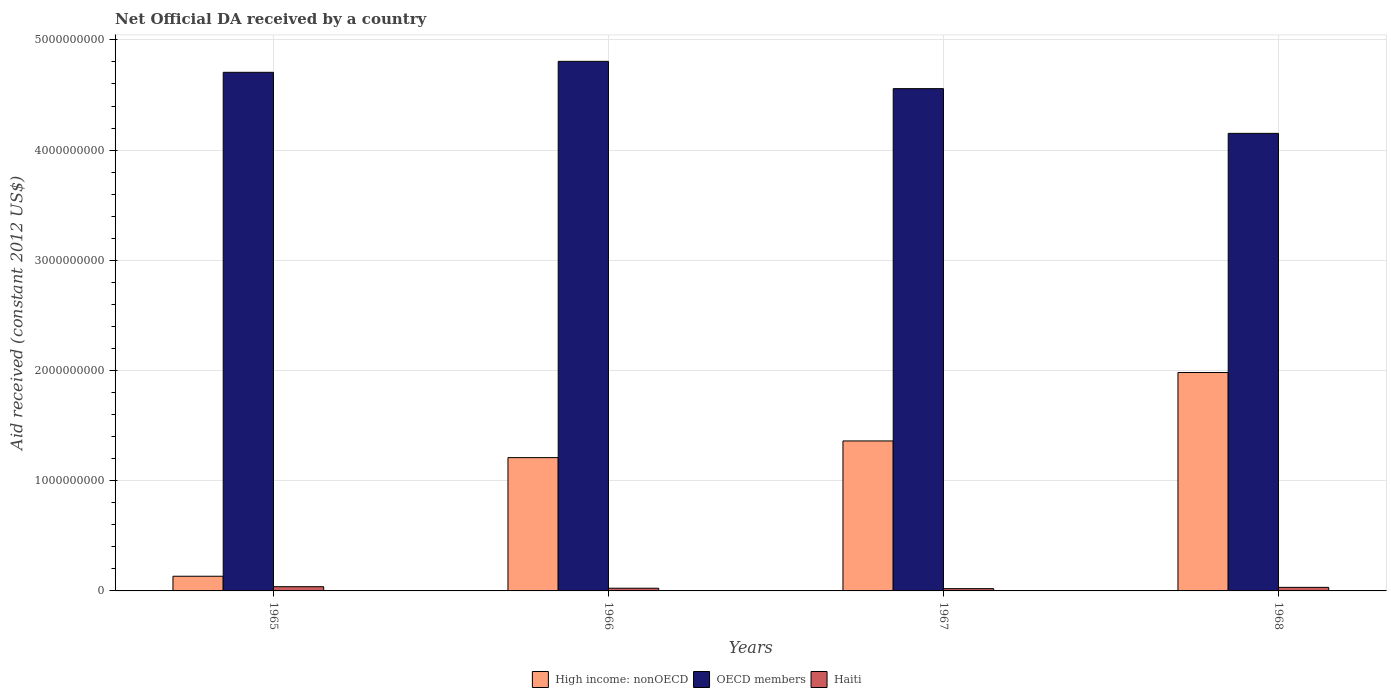Are the number of bars per tick equal to the number of legend labels?
Provide a short and direct response. Yes. Are the number of bars on each tick of the X-axis equal?
Offer a very short reply. Yes. How many bars are there on the 3rd tick from the left?
Provide a succinct answer. 3. What is the label of the 3rd group of bars from the left?
Your response must be concise. 1967. What is the net official development assistance aid received in Haiti in 1967?
Provide a short and direct response. 2.07e+07. Across all years, what is the maximum net official development assistance aid received in OECD members?
Your response must be concise. 4.81e+09. Across all years, what is the minimum net official development assistance aid received in High income: nonOECD?
Make the answer very short. 1.33e+08. In which year was the net official development assistance aid received in Haiti maximum?
Offer a terse response. 1965. In which year was the net official development assistance aid received in OECD members minimum?
Your response must be concise. 1968. What is the total net official development assistance aid received in Haiti in the graph?
Ensure brevity in your answer.  1.16e+08. What is the difference between the net official development assistance aid received in OECD members in 1965 and that in 1966?
Your answer should be very brief. -9.94e+07. What is the difference between the net official development assistance aid received in OECD members in 1968 and the net official development assistance aid received in High income: nonOECD in 1966?
Provide a short and direct response. 2.94e+09. What is the average net official development assistance aid received in High income: nonOECD per year?
Provide a succinct answer. 1.17e+09. In the year 1967, what is the difference between the net official development assistance aid received in OECD members and net official development assistance aid received in Haiti?
Provide a short and direct response. 4.54e+09. In how many years, is the net official development assistance aid received in OECD members greater than 3000000000 US$?
Provide a short and direct response. 4. What is the ratio of the net official development assistance aid received in High income: nonOECD in 1965 to that in 1968?
Offer a very short reply. 0.07. What is the difference between the highest and the second highest net official development assistance aid received in OECD members?
Your answer should be compact. 9.94e+07. What is the difference between the highest and the lowest net official development assistance aid received in High income: nonOECD?
Make the answer very short. 1.85e+09. Is the sum of the net official development assistance aid received in OECD members in 1965 and 1968 greater than the maximum net official development assistance aid received in Haiti across all years?
Ensure brevity in your answer.  Yes. What does the 2nd bar from the left in 1965 represents?
Provide a short and direct response. OECD members. What does the 2nd bar from the right in 1967 represents?
Keep it short and to the point. OECD members. Is it the case that in every year, the sum of the net official development assistance aid received in High income: nonOECD and net official development assistance aid received in OECD members is greater than the net official development assistance aid received in Haiti?
Provide a short and direct response. Yes. How many bars are there?
Ensure brevity in your answer.  12. Are all the bars in the graph horizontal?
Make the answer very short. No. Are the values on the major ticks of Y-axis written in scientific E-notation?
Give a very brief answer. No. Does the graph contain any zero values?
Provide a short and direct response. No. Where does the legend appear in the graph?
Your answer should be compact. Bottom center. How are the legend labels stacked?
Give a very brief answer. Horizontal. What is the title of the graph?
Keep it short and to the point. Net Official DA received by a country. Does "Bermuda" appear as one of the legend labels in the graph?
Your response must be concise. No. What is the label or title of the Y-axis?
Offer a very short reply. Aid received (constant 2012 US$). What is the Aid received (constant 2012 US$) of High income: nonOECD in 1965?
Your answer should be very brief. 1.33e+08. What is the Aid received (constant 2012 US$) of OECD members in 1965?
Provide a succinct answer. 4.71e+09. What is the Aid received (constant 2012 US$) in Haiti in 1965?
Provide a short and direct response. 3.84e+07. What is the Aid received (constant 2012 US$) of High income: nonOECD in 1966?
Ensure brevity in your answer.  1.21e+09. What is the Aid received (constant 2012 US$) of OECD members in 1966?
Keep it short and to the point. 4.81e+09. What is the Aid received (constant 2012 US$) in Haiti in 1966?
Give a very brief answer. 2.45e+07. What is the Aid received (constant 2012 US$) in High income: nonOECD in 1967?
Give a very brief answer. 1.36e+09. What is the Aid received (constant 2012 US$) in OECD members in 1967?
Offer a very short reply. 4.56e+09. What is the Aid received (constant 2012 US$) in Haiti in 1967?
Offer a very short reply. 2.07e+07. What is the Aid received (constant 2012 US$) in High income: nonOECD in 1968?
Ensure brevity in your answer.  1.98e+09. What is the Aid received (constant 2012 US$) in OECD members in 1968?
Offer a very short reply. 4.15e+09. What is the Aid received (constant 2012 US$) of Haiti in 1968?
Provide a succinct answer. 3.23e+07. Across all years, what is the maximum Aid received (constant 2012 US$) in High income: nonOECD?
Give a very brief answer. 1.98e+09. Across all years, what is the maximum Aid received (constant 2012 US$) of OECD members?
Make the answer very short. 4.81e+09. Across all years, what is the maximum Aid received (constant 2012 US$) in Haiti?
Offer a terse response. 3.84e+07. Across all years, what is the minimum Aid received (constant 2012 US$) of High income: nonOECD?
Your answer should be compact. 1.33e+08. Across all years, what is the minimum Aid received (constant 2012 US$) of OECD members?
Offer a very short reply. 4.15e+09. Across all years, what is the minimum Aid received (constant 2012 US$) in Haiti?
Your answer should be very brief. 2.07e+07. What is the total Aid received (constant 2012 US$) in High income: nonOECD in the graph?
Make the answer very short. 4.69e+09. What is the total Aid received (constant 2012 US$) in OECD members in the graph?
Give a very brief answer. 1.82e+1. What is the total Aid received (constant 2012 US$) of Haiti in the graph?
Give a very brief answer. 1.16e+08. What is the difference between the Aid received (constant 2012 US$) of High income: nonOECD in 1965 and that in 1966?
Give a very brief answer. -1.08e+09. What is the difference between the Aid received (constant 2012 US$) of OECD members in 1965 and that in 1966?
Your answer should be compact. -9.94e+07. What is the difference between the Aid received (constant 2012 US$) of Haiti in 1965 and that in 1966?
Give a very brief answer. 1.39e+07. What is the difference between the Aid received (constant 2012 US$) in High income: nonOECD in 1965 and that in 1967?
Give a very brief answer. -1.23e+09. What is the difference between the Aid received (constant 2012 US$) of OECD members in 1965 and that in 1967?
Your answer should be compact. 1.48e+08. What is the difference between the Aid received (constant 2012 US$) of Haiti in 1965 and that in 1967?
Provide a short and direct response. 1.77e+07. What is the difference between the Aid received (constant 2012 US$) in High income: nonOECD in 1965 and that in 1968?
Make the answer very short. -1.85e+09. What is the difference between the Aid received (constant 2012 US$) of OECD members in 1965 and that in 1968?
Make the answer very short. 5.54e+08. What is the difference between the Aid received (constant 2012 US$) of Haiti in 1965 and that in 1968?
Offer a very short reply. 6.11e+06. What is the difference between the Aid received (constant 2012 US$) in High income: nonOECD in 1966 and that in 1967?
Your answer should be very brief. -1.51e+08. What is the difference between the Aid received (constant 2012 US$) in OECD members in 1966 and that in 1967?
Your answer should be compact. 2.48e+08. What is the difference between the Aid received (constant 2012 US$) of Haiti in 1966 and that in 1967?
Make the answer very short. 3.80e+06. What is the difference between the Aid received (constant 2012 US$) in High income: nonOECD in 1966 and that in 1968?
Offer a very short reply. -7.72e+08. What is the difference between the Aid received (constant 2012 US$) in OECD members in 1966 and that in 1968?
Your response must be concise. 6.53e+08. What is the difference between the Aid received (constant 2012 US$) in Haiti in 1966 and that in 1968?
Offer a very short reply. -7.82e+06. What is the difference between the Aid received (constant 2012 US$) in High income: nonOECD in 1967 and that in 1968?
Your answer should be very brief. -6.21e+08. What is the difference between the Aid received (constant 2012 US$) of OECD members in 1967 and that in 1968?
Provide a short and direct response. 4.06e+08. What is the difference between the Aid received (constant 2012 US$) of Haiti in 1967 and that in 1968?
Your response must be concise. -1.16e+07. What is the difference between the Aid received (constant 2012 US$) of High income: nonOECD in 1965 and the Aid received (constant 2012 US$) of OECD members in 1966?
Provide a succinct answer. -4.67e+09. What is the difference between the Aid received (constant 2012 US$) of High income: nonOECD in 1965 and the Aid received (constant 2012 US$) of Haiti in 1966?
Your answer should be compact. 1.09e+08. What is the difference between the Aid received (constant 2012 US$) of OECD members in 1965 and the Aid received (constant 2012 US$) of Haiti in 1966?
Ensure brevity in your answer.  4.68e+09. What is the difference between the Aid received (constant 2012 US$) in High income: nonOECD in 1965 and the Aid received (constant 2012 US$) in OECD members in 1967?
Offer a terse response. -4.42e+09. What is the difference between the Aid received (constant 2012 US$) of High income: nonOECD in 1965 and the Aid received (constant 2012 US$) of Haiti in 1967?
Your answer should be very brief. 1.13e+08. What is the difference between the Aid received (constant 2012 US$) of OECD members in 1965 and the Aid received (constant 2012 US$) of Haiti in 1967?
Offer a terse response. 4.69e+09. What is the difference between the Aid received (constant 2012 US$) of High income: nonOECD in 1965 and the Aid received (constant 2012 US$) of OECD members in 1968?
Your answer should be compact. -4.02e+09. What is the difference between the Aid received (constant 2012 US$) in High income: nonOECD in 1965 and the Aid received (constant 2012 US$) in Haiti in 1968?
Ensure brevity in your answer.  1.01e+08. What is the difference between the Aid received (constant 2012 US$) in OECD members in 1965 and the Aid received (constant 2012 US$) in Haiti in 1968?
Your response must be concise. 4.67e+09. What is the difference between the Aid received (constant 2012 US$) in High income: nonOECD in 1966 and the Aid received (constant 2012 US$) in OECD members in 1967?
Ensure brevity in your answer.  -3.35e+09. What is the difference between the Aid received (constant 2012 US$) in High income: nonOECD in 1966 and the Aid received (constant 2012 US$) in Haiti in 1967?
Keep it short and to the point. 1.19e+09. What is the difference between the Aid received (constant 2012 US$) of OECD members in 1966 and the Aid received (constant 2012 US$) of Haiti in 1967?
Provide a short and direct response. 4.78e+09. What is the difference between the Aid received (constant 2012 US$) of High income: nonOECD in 1966 and the Aid received (constant 2012 US$) of OECD members in 1968?
Provide a short and direct response. -2.94e+09. What is the difference between the Aid received (constant 2012 US$) of High income: nonOECD in 1966 and the Aid received (constant 2012 US$) of Haiti in 1968?
Your response must be concise. 1.18e+09. What is the difference between the Aid received (constant 2012 US$) of OECD members in 1966 and the Aid received (constant 2012 US$) of Haiti in 1968?
Your answer should be very brief. 4.77e+09. What is the difference between the Aid received (constant 2012 US$) of High income: nonOECD in 1967 and the Aid received (constant 2012 US$) of OECD members in 1968?
Ensure brevity in your answer.  -2.79e+09. What is the difference between the Aid received (constant 2012 US$) in High income: nonOECD in 1967 and the Aid received (constant 2012 US$) in Haiti in 1968?
Your answer should be compact. 1.33e+09. What is the difference between the Aid received (constant 2012 US$) of OECD members in 1967 and the Aid received (constant 2012 US$) of Haiti in 1968?
Give a very brief answer. 4.53e+09. What is the average Aid received (constant 2012 US$) of High income: nonOECD per year?
Keep it short and to the point. 1.17e+09. What is the average Aid received (constant 2012 US$) of OECD members per year?
Ensure brevity in your answer.  4.56e+09. What is the average Aid received (constant 2012 US$) of Haiti per year?
Your answer should be very brief. 2.90e+07. In the year 1965, what is the difference between the Aid received (constant 2012 US$) of High income: nonOECD and Aid received (constant 2012 US$) of OECD members?
Offer a very short reply. -4.57e+09. In the year 1965, what is the difference between the Aid received (constant 2012 US$) in High income: nonOECD and Aid received (constant 2012 US$) in Haiti?
Give a very brief answer. 9.48e+07. In the year 1965, what is the difference between the Aid received (constant 2012 US$) of OECD members and Aid received (constant 2012 US$) of Haiti?
Your answer should be compact. 4.67e+09. In the year 1966, what is the difference between the Aid received (constant 2012 US$) of High income: nonOECD and Aid received (constant 2012 US$) of OECD members?
Your answer should be compact. -3.60e+09. In the year 1966, what is the difference between the Aid received (constant 2012 US$) in High income: nonOECD and Aid received (constant 2012 US$) in Haiti?
Provide a short and direct response. 1.19e+09. In the year 1966, what is the difference between the Aid received (constant 2012 US$) of OECD members and Aid received (constant 2012 US$) of Haiti?
Ensure brevity in your answer.  4.78e+09. In the year 1967, what is the difference between the Aid received (constant 2012 US$) of High income: nonOECD and Aid received (constant 2012 US$) of OECD members?
Your answer should be compact. -3.20e+09. In the year 1967, what is the difference between the Aid received (constant 2012 US$) of High income: nonOECD and Aid received (constant 2012 US$) of Haiti?
Give a very brief answer. 1.34e+09. In the year 1967, what is the difference between the Aid received (constant 2012 US$) of OECD members and Aid received (constant 2012 US$) of Haiti?
Ensure brevity in your answer.  4.54e+09. In the year 1968, what is the difference between the Aid received (constant 2012 US$) in High income: nonOECD and Aid received (constant 2012 US$) in OECD members?
Provide a short and direct response. -2.17e+09. In the year 1968, what is the difference between the Aid received (constant 2012 US$) in High income: nonOECD and Aid received (constant 2012 US$) in Haiti?
Offer a terse response. 1.95e+09. In the year 1968, what is the difference between the Aid received (constant 2012 US$) of OECD members and Aid received (constant 2012 US$) of Haiti?
Make the answer very short. 4.12e+09. What is the ratio of the Aid received (constant 2012 US$) in High income: nonOECD in 1965 to that in 1966?
Your answer should be very brief. 0.11. What is the ratio of the Aid received (constant 2012 US$) in OECD members in 1965 to that in 1966?
Offer a very short reply. 0.98. What is the ratio of the Aid received (constant 2012 US$) in Haiti in 1965 to that in 1966?
Give a very brief answer. 1.57. What is the ratio of the Aid received (constant 2012 US$) in High income: nonOECD in 1965 to that in 1967?
Your response must be concise. 0.1. What is the ratio of the Aid received (constant 2012 US$) in OECD members in 1965 to that in 1967?
Your answer should be very brief. 1.03. What is the ratio of the Aid received (constant 2012 US$) in Haiti in 1965 to that in 1967?
Offer a very short reply. 1.86. What is the ratio of the Aid received (constant 2012 US$) in High income: nonOECD in 1965 to that in 1968?
Your answer should be very brief. 0.07. What is the ratio of the Aid received (constant 2012 US$) of OECD members in 1965 to that in 1968?
Your response must be concise. 1.13. What is the ratio of the Aid received (constant 2012 US$) of Haiti in 1965 to that in 1968?
Provide a succinct answer. 1.19. What is the ratio of the Aid received (constant 2012 US$) in OECD members in 1966 to that in 1967?
Give a very brief answer. 1.05. What is the ratio of the Aid received (constant 2012 US$) in Haiti in 1966 to that in 1967?
Provide a succinct answer. 1.18. What is the ratio of the Aid received (constant 2012 US$) of High income: nonOECD in 1966 to that in 1968?
Provide a succinct answer. 0.61. What is the ratio of the Aid received (constant 2012 US$) in OECD members in 1966 to that in 1968?
Ensure brevity in your answer.  1.16. What is the ratio of the Aid received (constant 2012 US$) in Haiti in 1966 to that in 1968?
Your answer should be compact. 0.76. What is the ratio of the Aid received (constant 2012 US$) of High income: nonOECD in 1967 to that in 1968?
Provide a succinct answer. 0.69. What is the ratio of the Aid received (constant 2012 US$) of OECD members in 1967 to that in 1968?
Offer a terse response. 1.1. What is the ratio of the Aid received (constant 2012 US$) in Haiti in 1967 to that in 1968?
Offer a very short reply. 0.64. What is the difference between the highest and the second highest Aid received (constant 2012 US$) of High income: nonOECD?
Your answer should be compact. 6.21e+08. What is the difference between the highest and the second highest Aid received (constant 2012 US$) of OECD members?
Offer a very short reply. 9.94e+07. What is the difference between the highest and the second highest Aid received (constant 2012 US$) of Haiti?
Your answer should be very brief. 6.11e+06. What is the difference between the highest and the lowest Aid received (constant 2012 US$) in High income: nonOECD?
Offer a terse response. 1.85e+09. What is the difference between the highest and the lowest Aid received (constant 2012 US$) of OECD members?
Provide a short and direct response. 6.53e+08. What is the difference between the highest and the lowest Aid received (constant 2012 US$) in Haiti?
Offer a very short reply. 1.77e+07. 